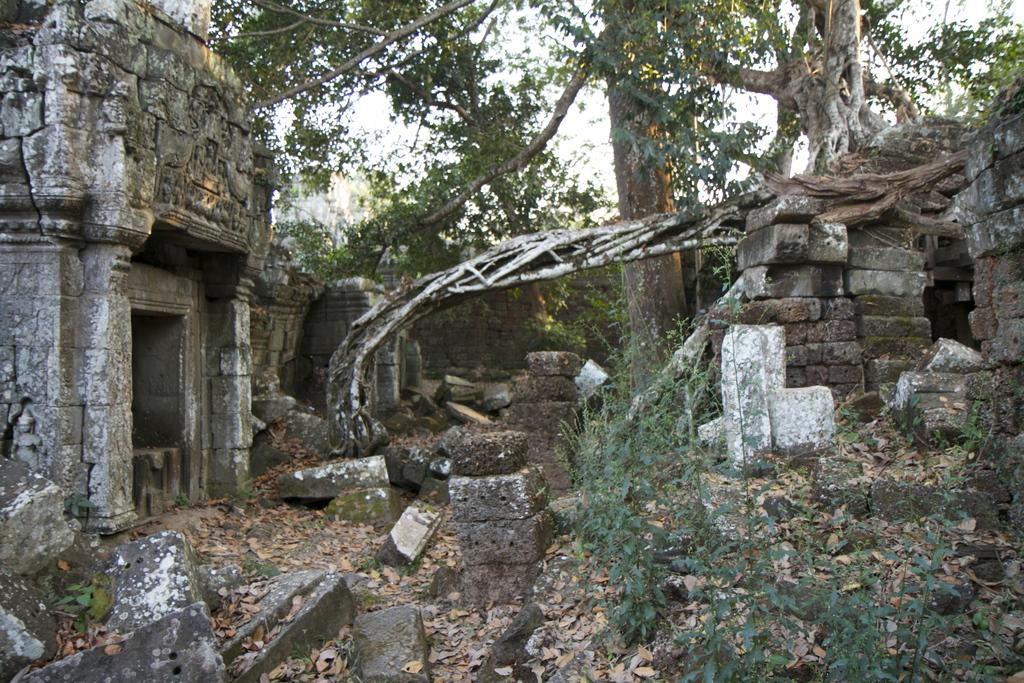What type of natural elements can be seen in the image? There are rocks and trees in the image. What additional items can be found in the image? Dry leaves are present in the image. Can you describe the other objects in the image? There are other objects in the image, but their specific details are not mentioned in the provided facts. What is visible in the background of the image? The sky is visible in the background of the image. What type of copper material can be seen in the image? There is no copper material present in the image. Is there any crime happening in the image? There is no indication of any crime in the image. 